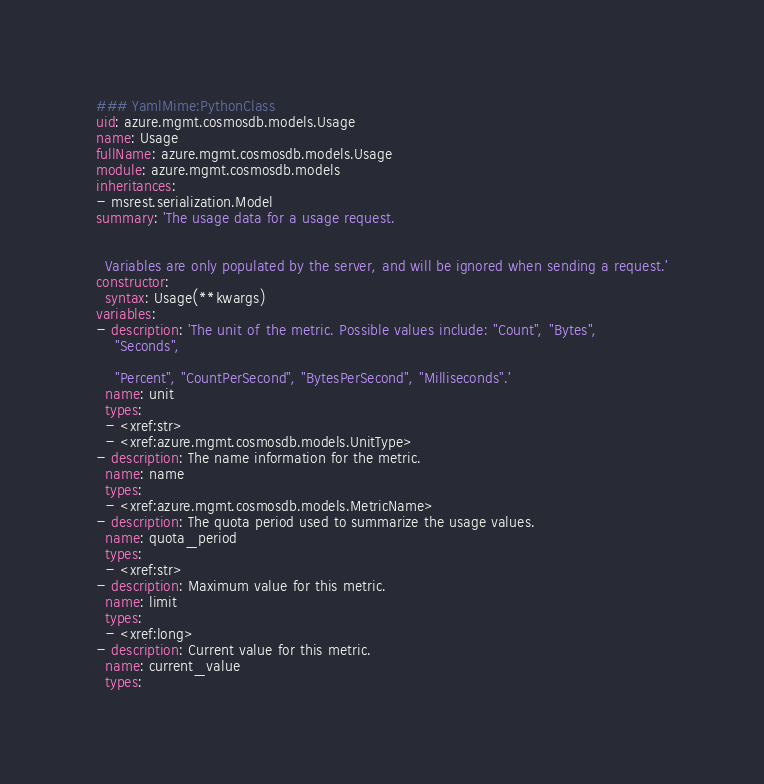<code> <loc_0><loc_0><loc_500><loc_500><_YAML_>### YamlMime:PythonClass
uid: azure.mgmt.cosmosdb.models.Usage
name: Usage
fullName: azure.mgmt.cosmosdb.models.Usage
module: azure.mgmt.cosmosdb.models
inheritances:
- msrest.serialization.Model
summary: 'The usage data for a usage request.


  Variables are only populated by the server, and will be ignored when sending a request.'
constructor:
  syntax: Usage(**kwargs)
variables:
- description: 'The unit of the metric. Possible values include: "Count", "Bytes",
    "Seconds",

    "Percent", "CountPerSecond", "BytesPerSecond", "Milliseconds".'
  name: unit
  types:
  - <xref:str>
  - <xref:azure.mgmt.cosmosdb.models.UnitType>
- description: The name information for the metric.
  name: name
  types:
  - <xref:azure.mgmt.cosmosdb.models.MetricName>
- description: The quota period used to summarize the usage values.
  name: quota_period
  types:
  - <xref:str>
- description: Maximum value for this metric.
  name: limit
  types:
  - <xref:long>
- description: Current value for this metric.
  name: current_value
  types:</code> 